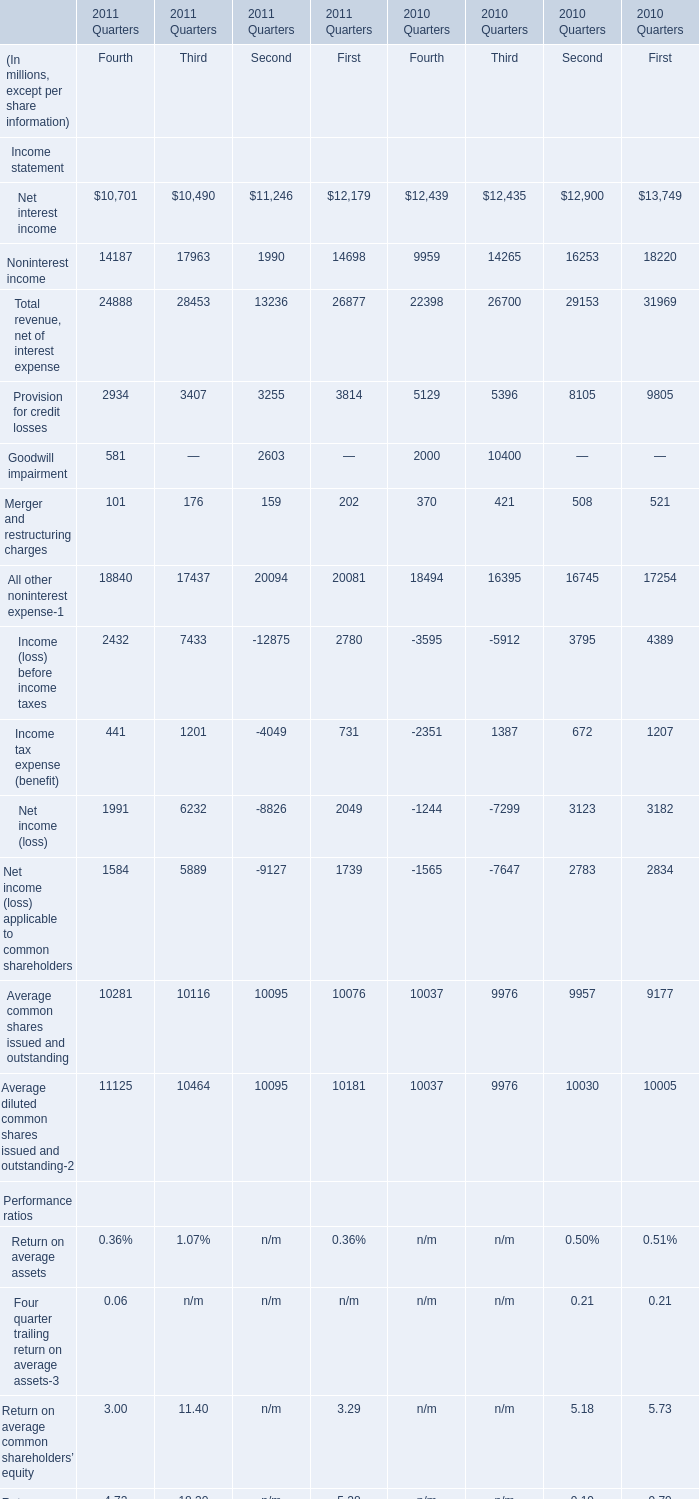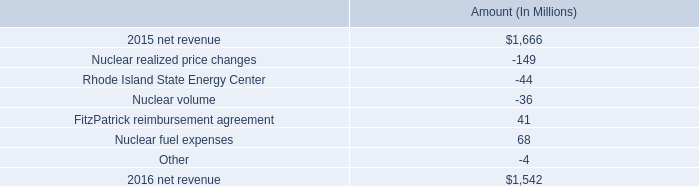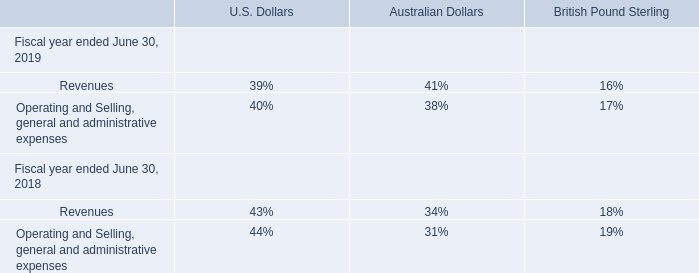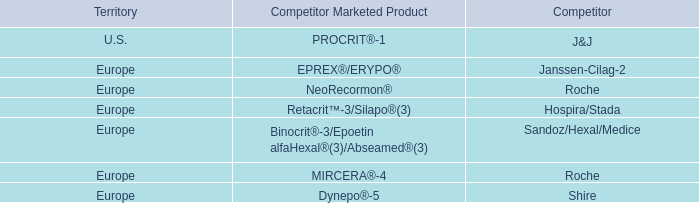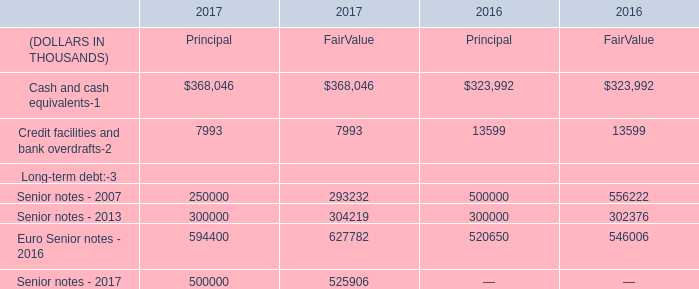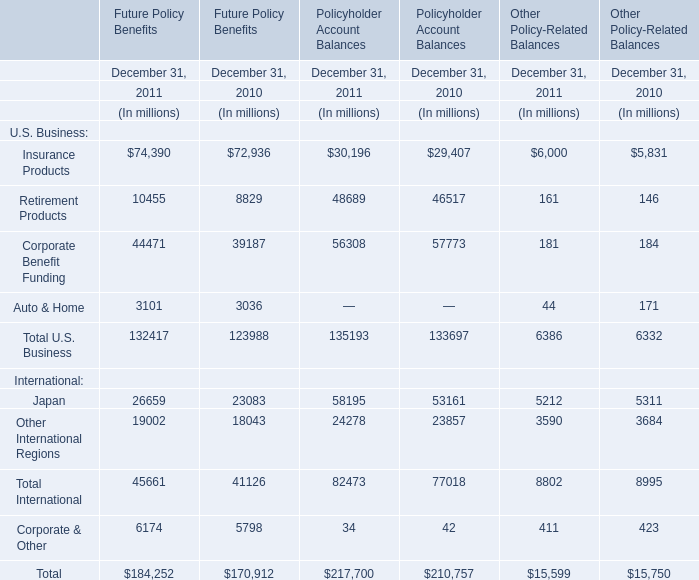What's the sum of the Net interest income in the years where Net interest income is positive for Fourth? (in million) 
Computations: (10701 + 12439)
Answer: 23140.0. 